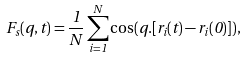Convert formula to latex. <formula><loc_0><loc_0><loc_500><loc_500>F _ { s } ( q , t ) = \frac { 1 } { N } \sum _ { i = 1 } ^ { N } \cos ( { q } . [ { r } _ { i } ( t ) - { r } _ { i } ( 0 ) ] ) ,</formula> 